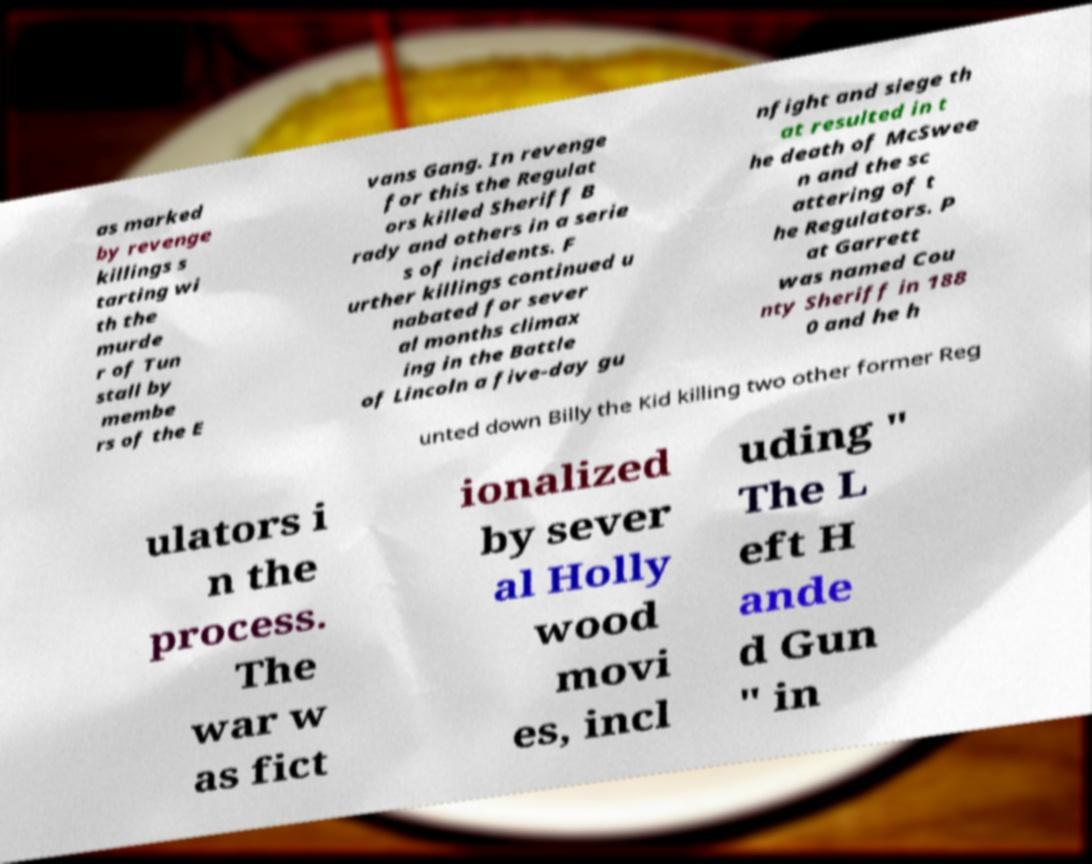Could you extract and type out the text from this image? as marked by revenge killings s tarting wi th the murde r of Tun stall by membe rs of the E vans Gang. In revenge for this the Regulat ors killed Sheriff B rady and others in a serie s of incidents. F urther killings continued u nabated for sever al months climax ing in the Battle of Lincoln a five-day gu nfight and siege th at resulted in t he death of McSwee n and the sc attering of t he Regulators. P at Garrett was named Cou nty Sheriff in 188 0 and he h unted down Billy the Kid killing two other former Reg ulators i n the process. The war w as fict ionalized by sever al Holly wood movi es, incl uding " The L eft H ande d Gun " in 